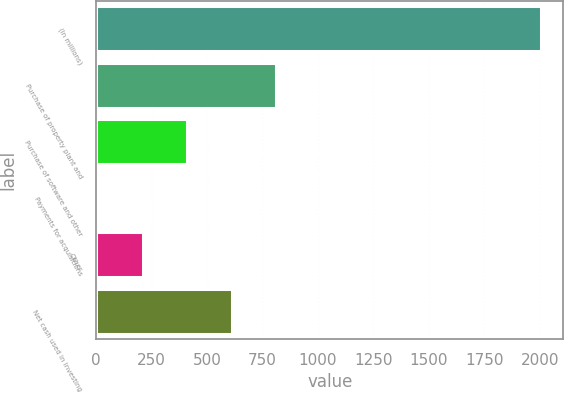<chart> <loc_0><loc_0><loc_500><loc_500><bar_chart><fcel>(In millions)<fcel>Purchase of property plant and<fcel>Purchase of software and other<fcel>Payments for acquisitions<fcel>Other<fcel>Net cash used in investing<nl><fcel>2006<fcel>810.44<fcel>411.92<fcel>13.4<fcel>212.66<fcel>611.18<nl></chart> 